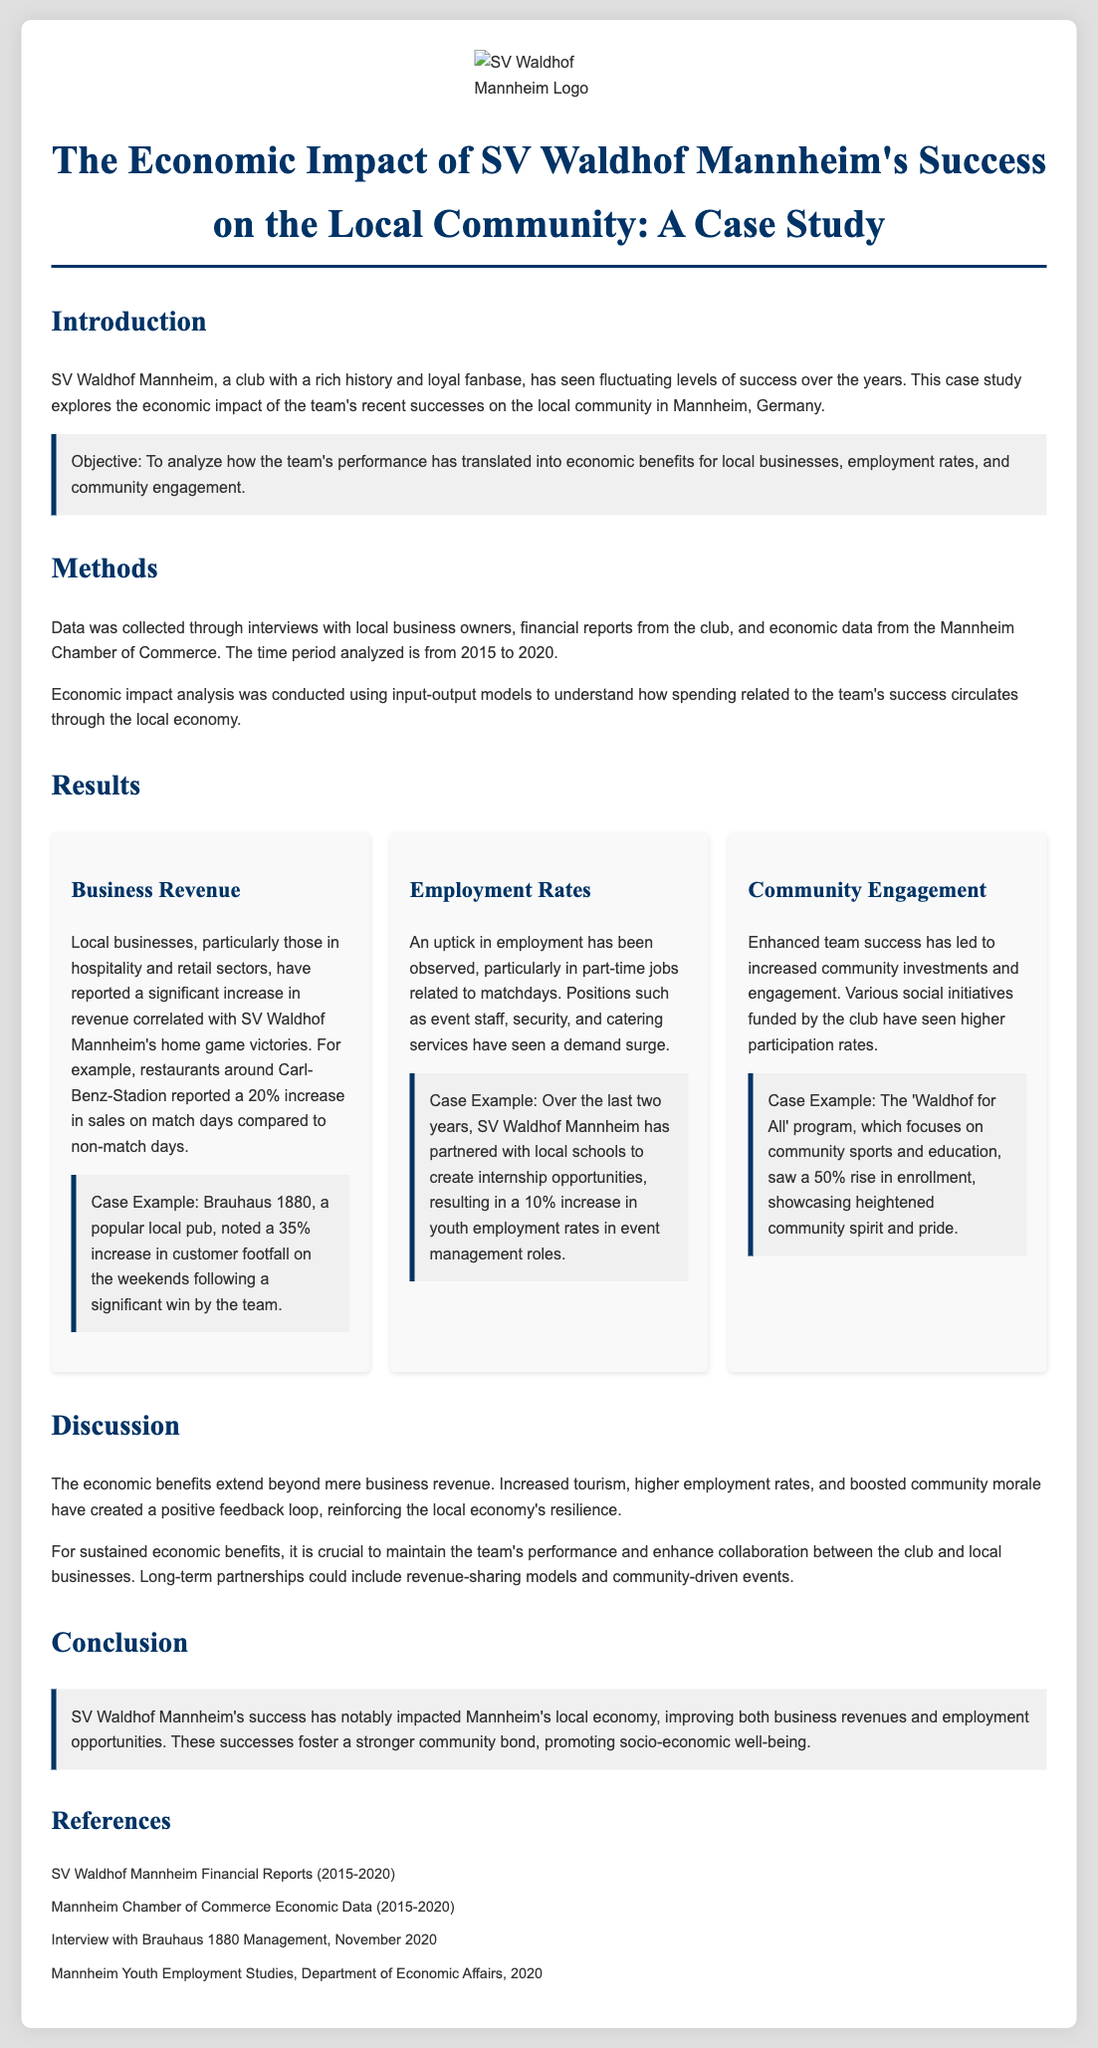what is the main objective of the study? The objective is to analyze how the team's performance has translated into economic benefits for local businesses, employment rates, and community engagement.
Answer: To analyze economic benefits what years does the study analyze? The time period analyzed in the study is from 2015 to 2020.
Answer: 2015 to 2020 which local business reported a 35% increase in customer footfall? The case example highlights Brauhaus 1880, a popular local pub, which noted this increase.
Answer: Brauhaus 1880 what was the increase in youth employment rates in event management roles? The study states that there was a 10% increase in youth employment rates in event management roles due to partnerships created by SV Waldhof Mannheim.
Answer: 10% how much did restaurants around Carl-Benz-Stadion report their sales increase on match days? On match days, restaurants reported a 20% increase in sales compared to non-match days.
Answer: 20% what program saw a 50% rise in enrollment? The 'Waldhof for All' program witnessed this rise in enrollment, showcasing heightened community spirit and pride.
Answer: Waldhof for All what is a crucial factor for sustained economic benefits according to the discussion? According to the discussion, maintaining the team's performance is crucial for sustained economic benefits.
Answer: Maintaining performance what type of analysis was used to understand the economic impact? The report utilized input-output models to analyze economic impacts.
Answer: Input-output models 